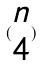Convert formula to latex. <formula><loc_0><loc_0><loc_500><loc_500>( \begin{matrix} n \\ 4 \end{matrix} )</formula> 